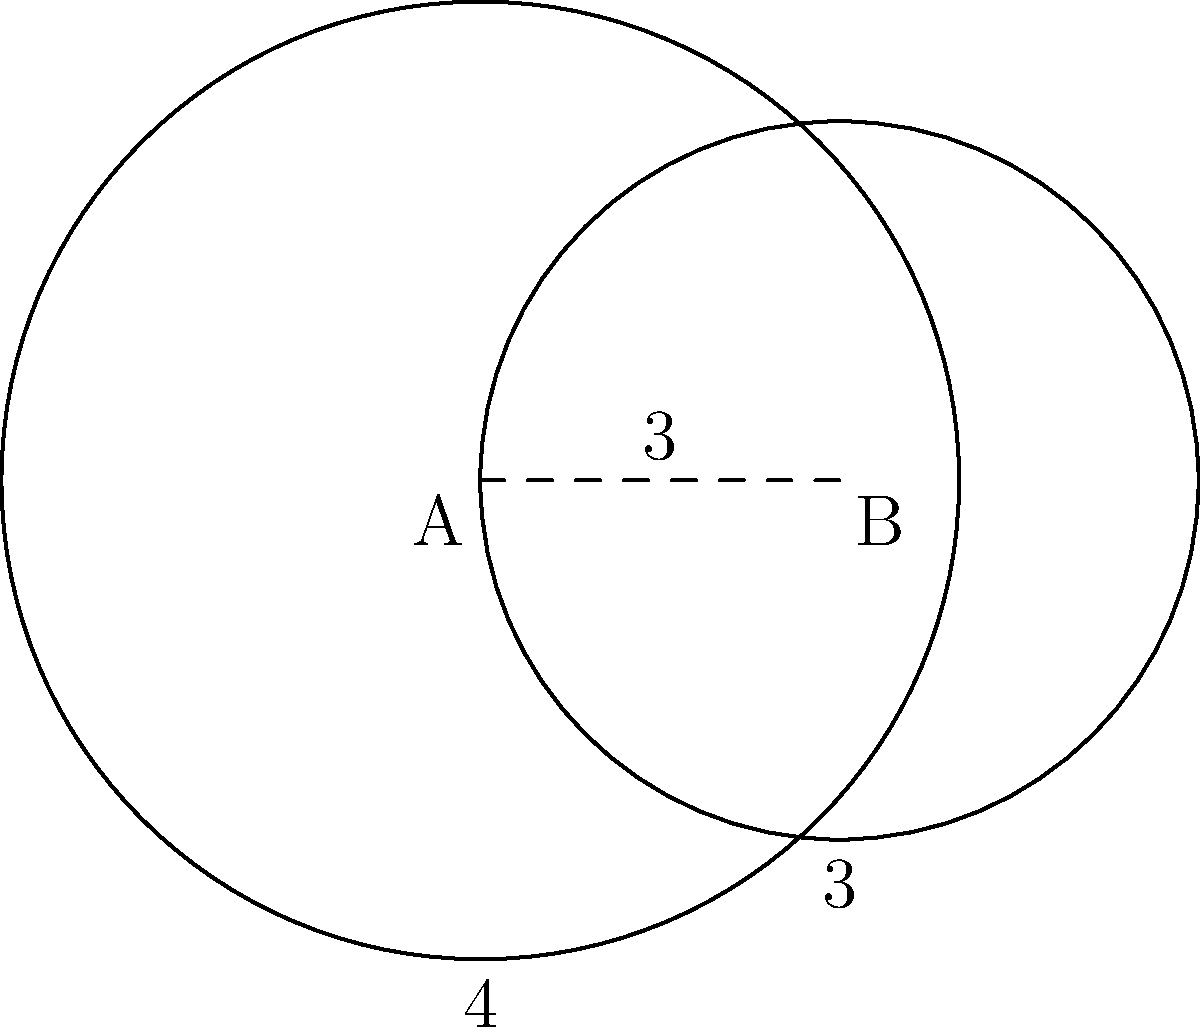As a branding expert, you're designing a logo that involves overlapping circular filters. Two circular filters with radii 4 and 3 units have their centers 3 units apart. Calculate the area of the overlapping region to determine the optimal blend of colors. Round your answer to two decimal places. Let's approach this step-by-step:

1) First, we need to find the distance from the center of each circle to the line of intersection. Let's call these distances $x$ and $y$ for the circles with radii 4 and 3 respectively.

2) We can use the Pythagorean theorem:

   $4^2 = x^2 + (\frac{3}{2})^2$
   $3^2 = y^2 + (\frac{3}{2})^2$

3) Solving these equations:

   $x = \sqrt{16 - \frac{9}{4}} = \sqrt{\frac{55}{4}} = \frac{\sqrt{55}}{2}$
   $y = \sqrt{9 - \frac{9}{4}} = \frac{3\sqrt{3}}{2}$

4) The area of intersection is the sum of two circular segments. The area of a circular segment is given by:

   $A = r^2 \arccos(\frac{d}{r}) - d\sqrt{r^2 - d^2}$

   where $r$ is the radius and $d$ is the distance from the center to the chord.

5) For the larger circle:

   $A_1 = 4^2 \arccos(\frac{\sqrt{55}}{8}) - \frac{\sqrt{55}}{2}\sqrt{16 - \frac{55}{4}}$

6) For the smaller circle:

   $A_2 = 3^2 \arccos(\frac{3\sqrt{3}}{6}) - \frac{3\sqrt{3}}{2}\sqrt{9 - \frac{27}{4}}$

7) The total area of intersection is $A = A_1 + A_2$

8) Calculating this (you would use a calculator):

   $A \approx 4.47 + 3.14 = 7.61$ square units
Answer: 7.61 square units 